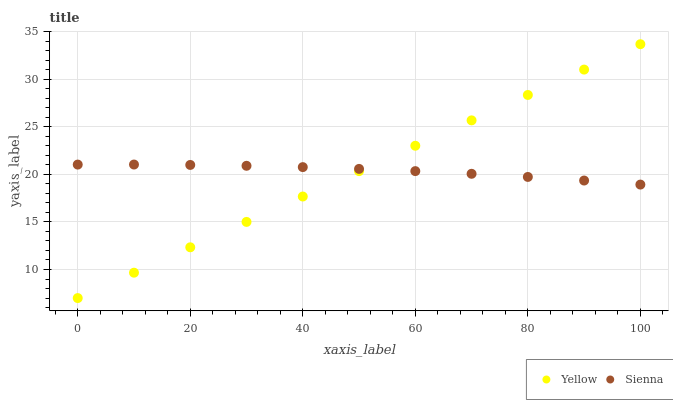Does Yellow have the minimum area under the curve?
Answer yes or no. Yes. Does Sienna have the maximum area under the curve?
Answer yes or no. Yes. Does Yellow have the maximum area under the curve?
Answer yes or no. No. Is Yellow the smoothest?
Answer yes or no. Yes. Is Sienna the roughest?
Answer yes or no. Yes. Is Yellow the roughest?
Answer yes or no. No. Does Yellow have the lowest value?
Answer yes or no. Yes. Does Yellow have the highest value?
Answer yes or no. Yes. Does Sienna intersect Yellow?
Answer yes or no. Yes. Is Sienna less than Yellow?
Answer yes or no. No. Is Sienna greater than Yellow?
Answer yes or no. No. 